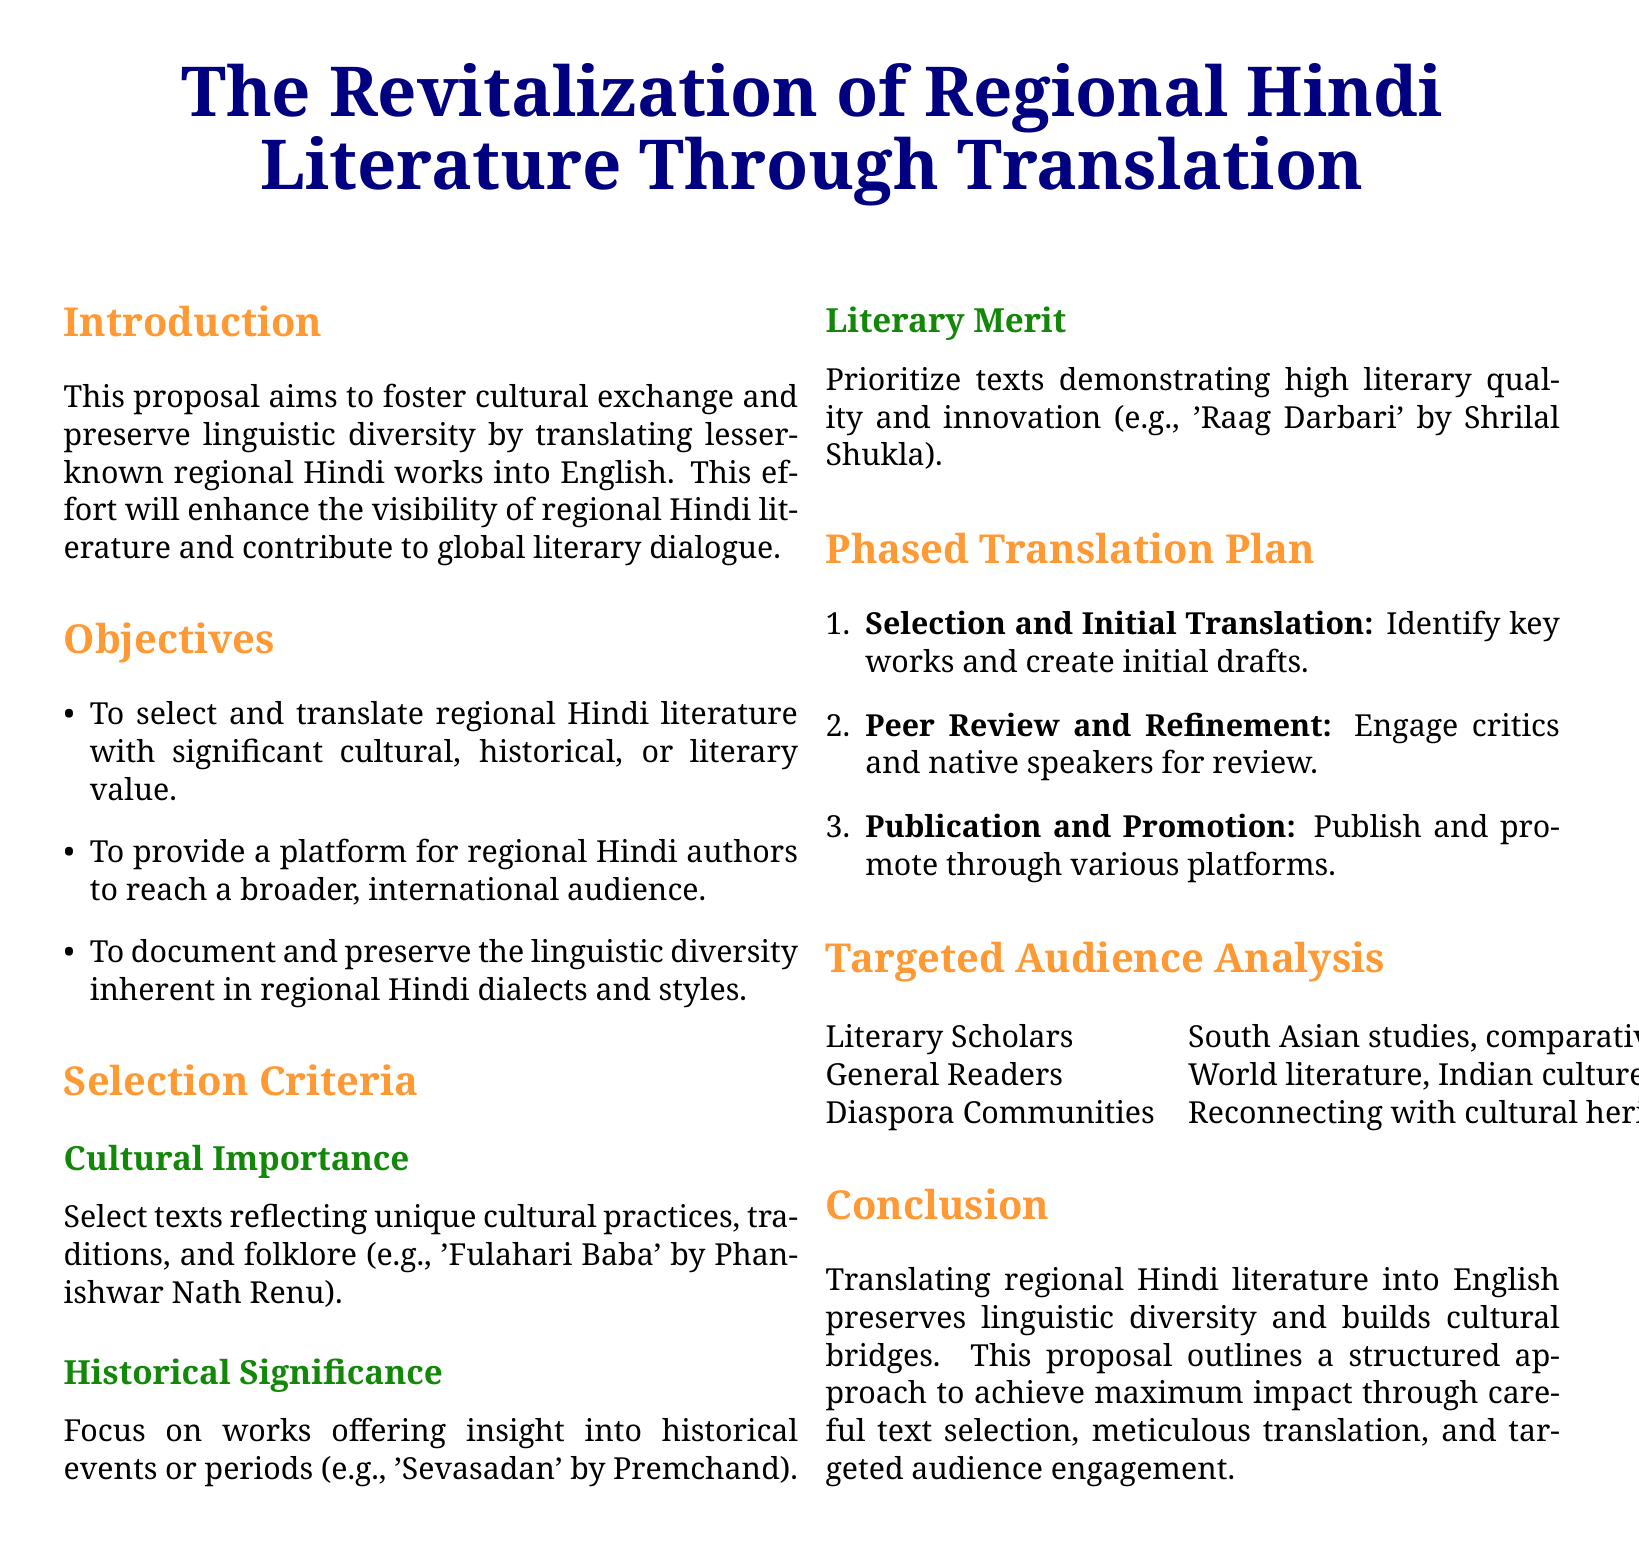What is the title of the proposal? The title is stated prominently at the top of the document.
Answer: The Revitalization of Regional Hindi Literature Through Translation What is one objective of the proposal? The objectives are listed in the document. One objective is to select and translate regional Hindi literature with significant cultural, historical, or literary value.
Answer: To select and translate regional Hindi literature with significant cultural, historical, or literary value Which author is mentioned for cultural importance criteria? The proposal lists specific works and their authors under the selection criteria.
Answer: Phanishwar Nath Renu What is the first step in the phased translation plan? The steps of the translation plan are outlined clearly in the document, with the first step mentioned.
Answer: Selection and Initial Translation Who are the targeted audience for the translated works? The proposal mentions specific groups in the targeted audience analysis section.
Answer: Literary Scholars, General Readers, Diaspora Communities What type of cultural aspects do the texts reflect? The document specifies the criteria for cultural importance in text selection.
Answer: Cultural practices, traditions, and folklore What is the primary goal of translating regional Hindi literature? The introduction states the goal of the proposal.
Answer: Foster cultural exchange and preserve linguistic diversity How many steps are there in the phased translation plan? The plan lists its structure in an enumerated format.
Answer: Three steps 